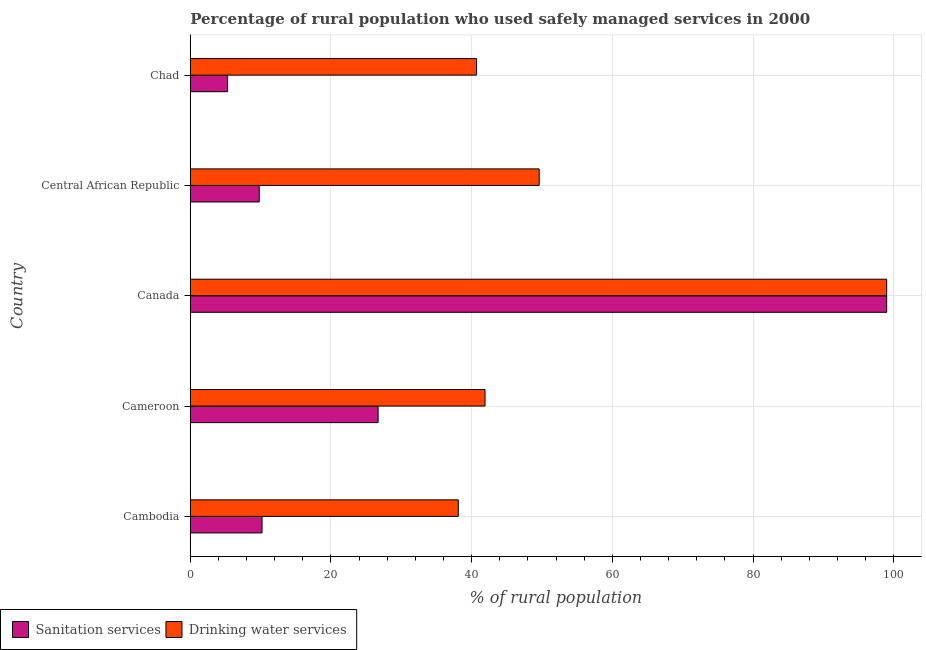How many different coloured bars are there?
Your answer should be very brief. 2. How many groups of bars are there?
Your answer should be compact. 5. Are the number of bars per tick equal to the number of legend labels?
Provide a succinct answer. Yes. What is the label of the 4th group of bars from the top?
Your answer should be very brief. Cameroon. In how many cases, is the number of bars for a given country not equal to the number of legend labels?
Your answer should be very brief. 0. What is the percentage of rural population who used drinking water services in Central African Republic?
Keep it short and to the point. 49.6. Across all countries, what is the maximum percentage of rural population who used sanitation services?
Provide a succinct answer. 99. Across all countries, what is the minimum percentage of rural population who used drinking water services?
Offer a terse response. 38.1. In which country was the percentage of rural population who used sanitation services minimum?
Your answer should be compact. Chad. What is the total percentage of rural population who used sanitation services in the graph?
Offer a very short reply. 151. What is the difference between the percentage of rural population who used sanitation services in Cameroon and the percentage of rural population who used drinking water services in Chad?
Provide a short and direct response. -14. What is the average percentage of rural population who used sanitation services per country?
Make the answer very short. 30.2. What is the difference between the percentage of rural population who used drinking water services and percentage of rural population who used sanitation services in Cameroon?
Your answer should be very brief. 15.2. What is the ratio of the percentage of rural population who used sanitation services in Cameroon to that in Central African Republic?
Your answer should be compact. 2.72. Is the difference between the percentage of rural population who used drinking water services in Canada and Central African Republic greater than the difference between the percentage of rural population who used sanitation services in Canada and Central African Republic?
Your answer should be compact. No. What is the difference between the highest and the second highest percentage of rural population who used drinking water services?
Your answer should be very brief. 49.4. What is the difference between the highest and the lowest percentage of rural population who used drinking water services?
Your response must be concise. 60.9. In how many countries, is the percentage of rural population who used sanitation services greater than the average percentage of rural population who used sanitation services taken over all countries?
Your answer should be compact. 1. Is the sum of the percentage of rural population who used drinking water services in Central African Republic and Chad greater than the maximum percentage of rural population who used sanitation services across all countries?
Offer a terse response. No. What does the 2nd bar from the top in Central African Republic represents?
Offer a very short reply. Sanitation services. What does the 1st bar from the bottom in Cameroon represents?
Give a very brief answer. Sanitation services. Are all the bars in the graph horizontal?
Keep it short and to the point. Yes. What is the difference between two consecutive major ticks on the X-axis?
Provide a short and direct response. 20. Are the values on the major ticks of X-axis written in scientific E-notation?
Give a very brief answer. No. Where does the legend appear in the graph?
Provide a succinct answer. Bottom left. How are the legend labels stacked?
Ensure brevity in your answer.  Horizontal. What is the title of the graph?
Offer a terse response. Percentage of rural population who used safely managed services in 2000. What is the label or title of the X-axis?
Your answer should be compact. % of rural population. What is the label or title of the Y-axis?
Your answer should be very brief. Country. What is the % of rural population in Drinking water services in Cambodia?
Give a very brief answer. 38.1. What is the % of rural population of Sanitation services in Cameroon?
Your answer should be very brief. 26.7. What is the % of rural population of Drinking water services in Cameroon?
Your answer should be compact. 41.9. What is the % of rural population in Drinking water services in Canada?
Keep it short and to the point. 99. What is the % of rural population in Drinking water services in Central African Republic?
Your answer should be very brief. 49.6. What is the % of rural population in Drinking water services in Chad?
Your response must be concise. 40.7. Across all countries, what is the maximum % of rural population in Drinking water services?
Your answer should be very brief. 99. Across all countries, what is the minimum % of rural population in Sanitation services?
Offer a terse response. 5.3. Across all countries, what is the minimum % of rural population of Drinking water services?
Provide a succinct answer. 38.1. What is the total % of rural population in Sanitation services in the graph?
Ensure brevity in your answer.  151. What is the total % of rural population of Drinking water services in the graph?
Give a very brief answer. 269.3. What is the difference between the % of rural population in Sanitation services in Cambodia and that in Cameroon?
Make the answer very short. -16.5. What is the difference between the % of rural population of Drinking water services in Cambodia and that in Cameroon?
Ensure brevity in your answer.  -3.8. What is the difference between the % of rural population in Sanitation services in Cambodia and that in Canada?
Your answer should be compact. -88.8. What is the difference between the % of rural population of Drinking water services in Cambodia and that in Canada?
Offer a terse response. -60.9. What is the difference between the % of rural population of Drinking water services in Cambodia and that in Central African Republic?
Offer a terse response. -11.5. What is the difference between the % of rural population of Sanitation services in Cambodia and that in Chad?
Provide a succinct answer. 4.9. What is the difference between the % of rural population in Drinking water services in Cambodia and that in Chad?
Ensure brevity in your answer.  -2.6. What is the difference between the % of rural population in Sanitation services in Cameroon and that in Canada?
Make the answer very short. -72.3. What is the difference between the % of rural population of Drinking water services in Cameroon and that in Canada?
Make the answer very short. -57.1. What is the difference between the % of rural population of Sanitation services in Cameroon and that in Chad?
Offer a terse response. 21.4. What is the difference between the % of rural population of Drinking water services in Cameroon and that in Chad?
Provide a succinct answer. 1.2. What is the difference between the % of rural population in Sanitation services in Canada and that in Central African Republic?
Offer a very short reply. 89.2. What is the difference between the % of rural population in Drinking water services in Canada and that in Central African Republic?
Give a very brief answer. 49.4. What is the difference between the % of rural population of Sanitation services in Canada and that in Chad?
Ensure brevity in your answer.  93.7. What is the difference between the % of rural population in Drinking water services in Canada and that in Chad?
Give a very brief answer. 58.3. What is the difference between the % of rural population in Drinking water services in Central African Republic and that in Chad?
Offer a very short reply. 8.9. What is the difference between the % of rural population in Sanitation services in Cambodia and the % of rural population in Drinking water services in Cameroon?
Keep it short and to the point. -31.7. What is the difference between the % of rural population in Sanitation services in Cambodia and the % of rural population in Drinking water services in Canada?
Your response must be concise. -88.8. What is the difference between the % of rural population in Sanitation services in Cambodia and the % of rural population in Drinking water services in Central African Republic?
Offer a terse response. -39.4. What is the difference between the % of rural population in Sanitation services in Cambodia and the % of rural population in Drinking water services in Chad?
Make the answer very short. -30.5. What is the difference between the % of rural population in Sanitation services in Cameroon and the % of rural population in Drinking water services in Canada?
Your answer should be very brief. -72.3. What is the difference between the % of rural population in Sanitation services in Cameroon and the % of rural population in Drinking water services in Central African Republic?
Make the answer very short. -22.9. What is the difference between the % of rural population in Sanitation services in Cameroon and the % of rural population in Drinking water services in Chad?
Give a very brief answer. -14. What is the difference between the % of rural population of Sanitation services in Canada and the % of rural population of Drinking water services in Central African Republic?
Your answer should be very brief. 49.4. What is the difference between the % of rural population of Sanitation services in Canada and the % of rural population of Drinking water services in Chad?
Offer a very short reply. 58.3. What is the difference between the % of rural population of Sanitation services in Central African Republic and the % of rural population of Drinking water services in Chad?
Ensure brevity in your answer.  -30.9. What is the average % of rural population of Sanitation services per country?
Provide a succinct answer. 30.2. What is the average % of rural population of Drinking water services per country?
Your answer should be compact. 53.86. What is the difference between the % of rural population in Sanitation services and % of rural population in Drinking water services in Cambodia?
Provide a short and direct response. -27.9. What is the difference between the % of rural population in Sanitation services and % of rural population in Drinking water services in Cameroon?
Give a very brief answer. -15.2. What is the difference between the % of rural population in Sanitation services and % of rural population in Drinking water services in Canada?
Offer a terse response. 0. What is the difference between the % of rural population in Sanitation services and % of rural population in Drinking water services in Central African Republic?
Offer a terse response. -39.8. What is the difference between the % of rural population of Sanitation services and % of rural population of Drinking water services in Chad?
Give a very brief answer. -35.4. What is the ratio of the % of rural population in Sanitation services in Cambodia to that in Cameroon?
Your response must be concise. 0.38. What is the ratio of the % of rural population of Drinking water services in Cambodia to that in Cameroon?
Your response must be concise. 0.91. What is the ratio of the % of rural population in Sanitation services in Cambodia to that in Canada?
Make the answer very short. 0.1. What is the ratio of the % of rural population in Drinking water services in Cambodia to that in Canada?
Provide a short and direct response. 0.38. What is the ratio of the % of rural population of Sanitation services in Cambodia to that in Central African Republic?
Make the answer very short. 1.04. What is the ratio of the % of rural population in Drinking water services in Cambodia to that in Central African Republic?
Give a very brief answer. 0.77. What is the ratio of the % of rural population in Sanitation services in Cambodia to that in Chad?
Your answer should be very brief. 1.92. What is the ratio of the % of rural population of Drinking water services in Cambodia to that in Chad?
Ensure brevity in your answer.  0.94. What is the ratio of the % of rural population in Sanitation services in Cameroon to that in Canada?
Make the answer very short. 0.27. What is the ratio of the % of rural population in Drinking water services in Cameroon to that in Canada?
Give a very brief answer. 0.42. What is the ratio of the % of rural population in Sanitation services in Cameroon to that in Central African Republic?
Give a very brief answer. 2.72. What is the ratio of the % of rural population of Drinking water services in Cameroon to that in Central African Republic?
Keep it short and to the point. 0.84. What is the ratio of the % of rural population in Sanitation services in Cameroon to that in Chad?
Provide a succinct answer. 5.04. What is the ratio of the % of rural population of Drinking water services in Cameroon to that in Chad?
Make the answer very short. 1.03. What is the ratio of the % of rural population in Sanitation services in Canada to that in Central African Republic?
Your response must be concise. 10.1. What is the ratio of the % of rural population in Drinking water services in Canada to that in Central African Republic?
Your answer should be compact. 2. What is the ratio of the % of rural population in Sanitation services in Canada to that in Chad?
Provide a succinct answer. 18.68. What is the ratio of the % of rural population of Drinking water services in Canada to that in Chad?
Your answer should be compact. 2.43. What is the ratio of the % of rural population in Sanitation services in Central African Republic to that in Chad?
Your response must be concise. 1.85. What is the ratio of the % of rural population in Drinking water services in Central African Republic to that in Chad?
Offer a very short reply. 1.22. What is the difference between the highest and the second highest % of rural population of Sanitation services?
Offer a terse response. 72.3. What is the difference between the highest and the second highest % of rural population in Drinking water services?
Give a very brief answer. 49.4. What is the difference between the highest and the lowest % of rural population of Sanitation services?
Your answer should be very brief. 93.7. What is the difference between the highest and the lowest % of rural population in Drinking water services?
Your answer should be very brief. 60.9. 